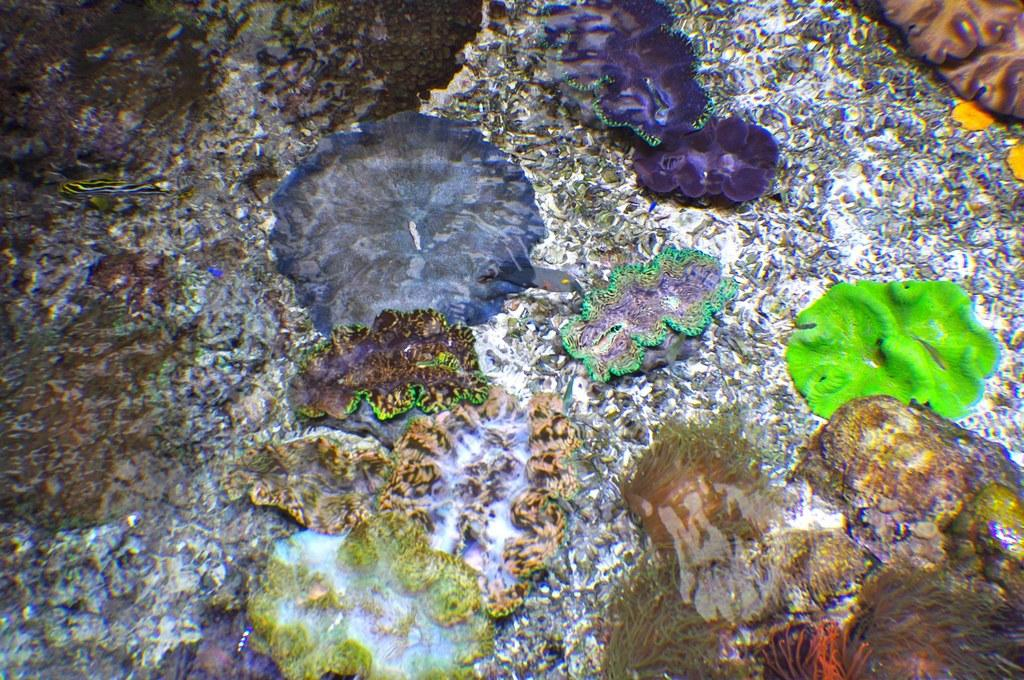What colors are present in the objects in the image? There is a green object, a blue object, a purple object, and a white object in the image. Can you describe the objects in the image based on their colors? Yes, there is a green object, a blue object, a purple object, and a white object in the image. What type of achievement is the green object celebrating in the image? There is no indication in the image that the green object is celebrating any achievement, as it is simply an object with a color. 